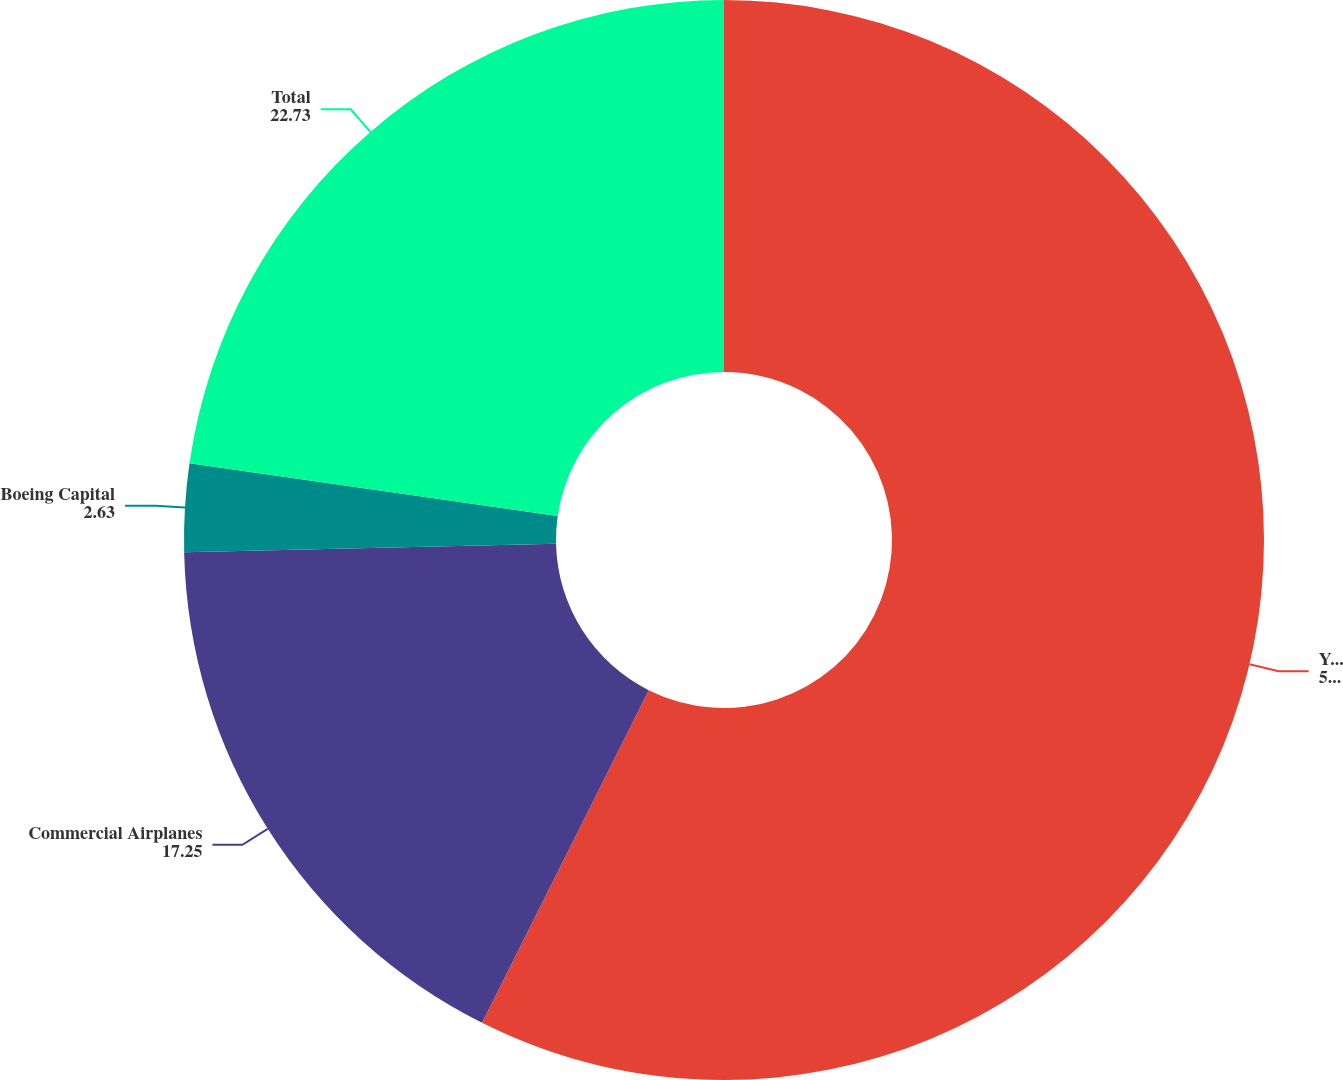Convert chart. <chart><loc_0><loc_0><loc_500><loc_500><pie_chart><fcel>Years ended December 31<fcel>Commercial Airplanes<fcel>Boeing Capital<fcel>Total<nl><fcel>57.4%<fcel>17.25%<fcel>2.63%<fcel>22.73%<nl></chart> 